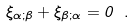<formula> <loc_0><loc_0><loc_500><loc_500>\xi _ { \alpha ; \beta } + \xi _ { \beta ; \alpha } = 0 \ .</formula> 